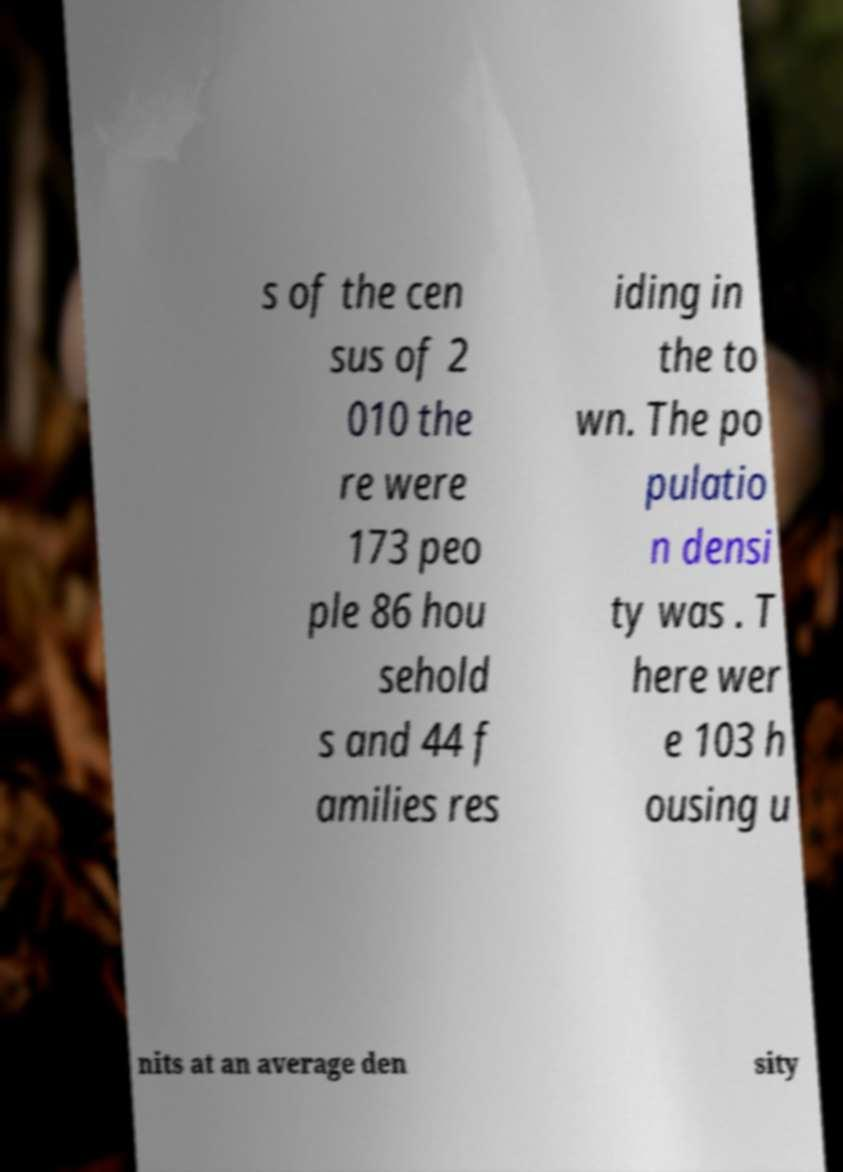Please read and relay the text visible in this image. What does it say? s of the cen sus of 2 010 the re were 173 peo ple 86 hou sehold s and 44 f amilies res iding in the to wn. The po pulatio n densi ty was . T here wer e 103 h ousing u nits at an average den sity 